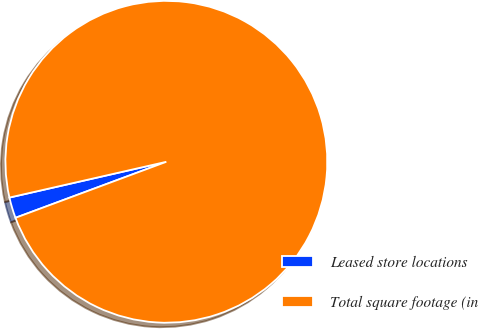Convert chart. <chart><loc_0><loc_0><loc_500><loc_500><pie_chart><fcel>Leased store locations<fcel>Total square footage (in<nl><fcel>2.09%<fcel>97.91%<nl></chart> 